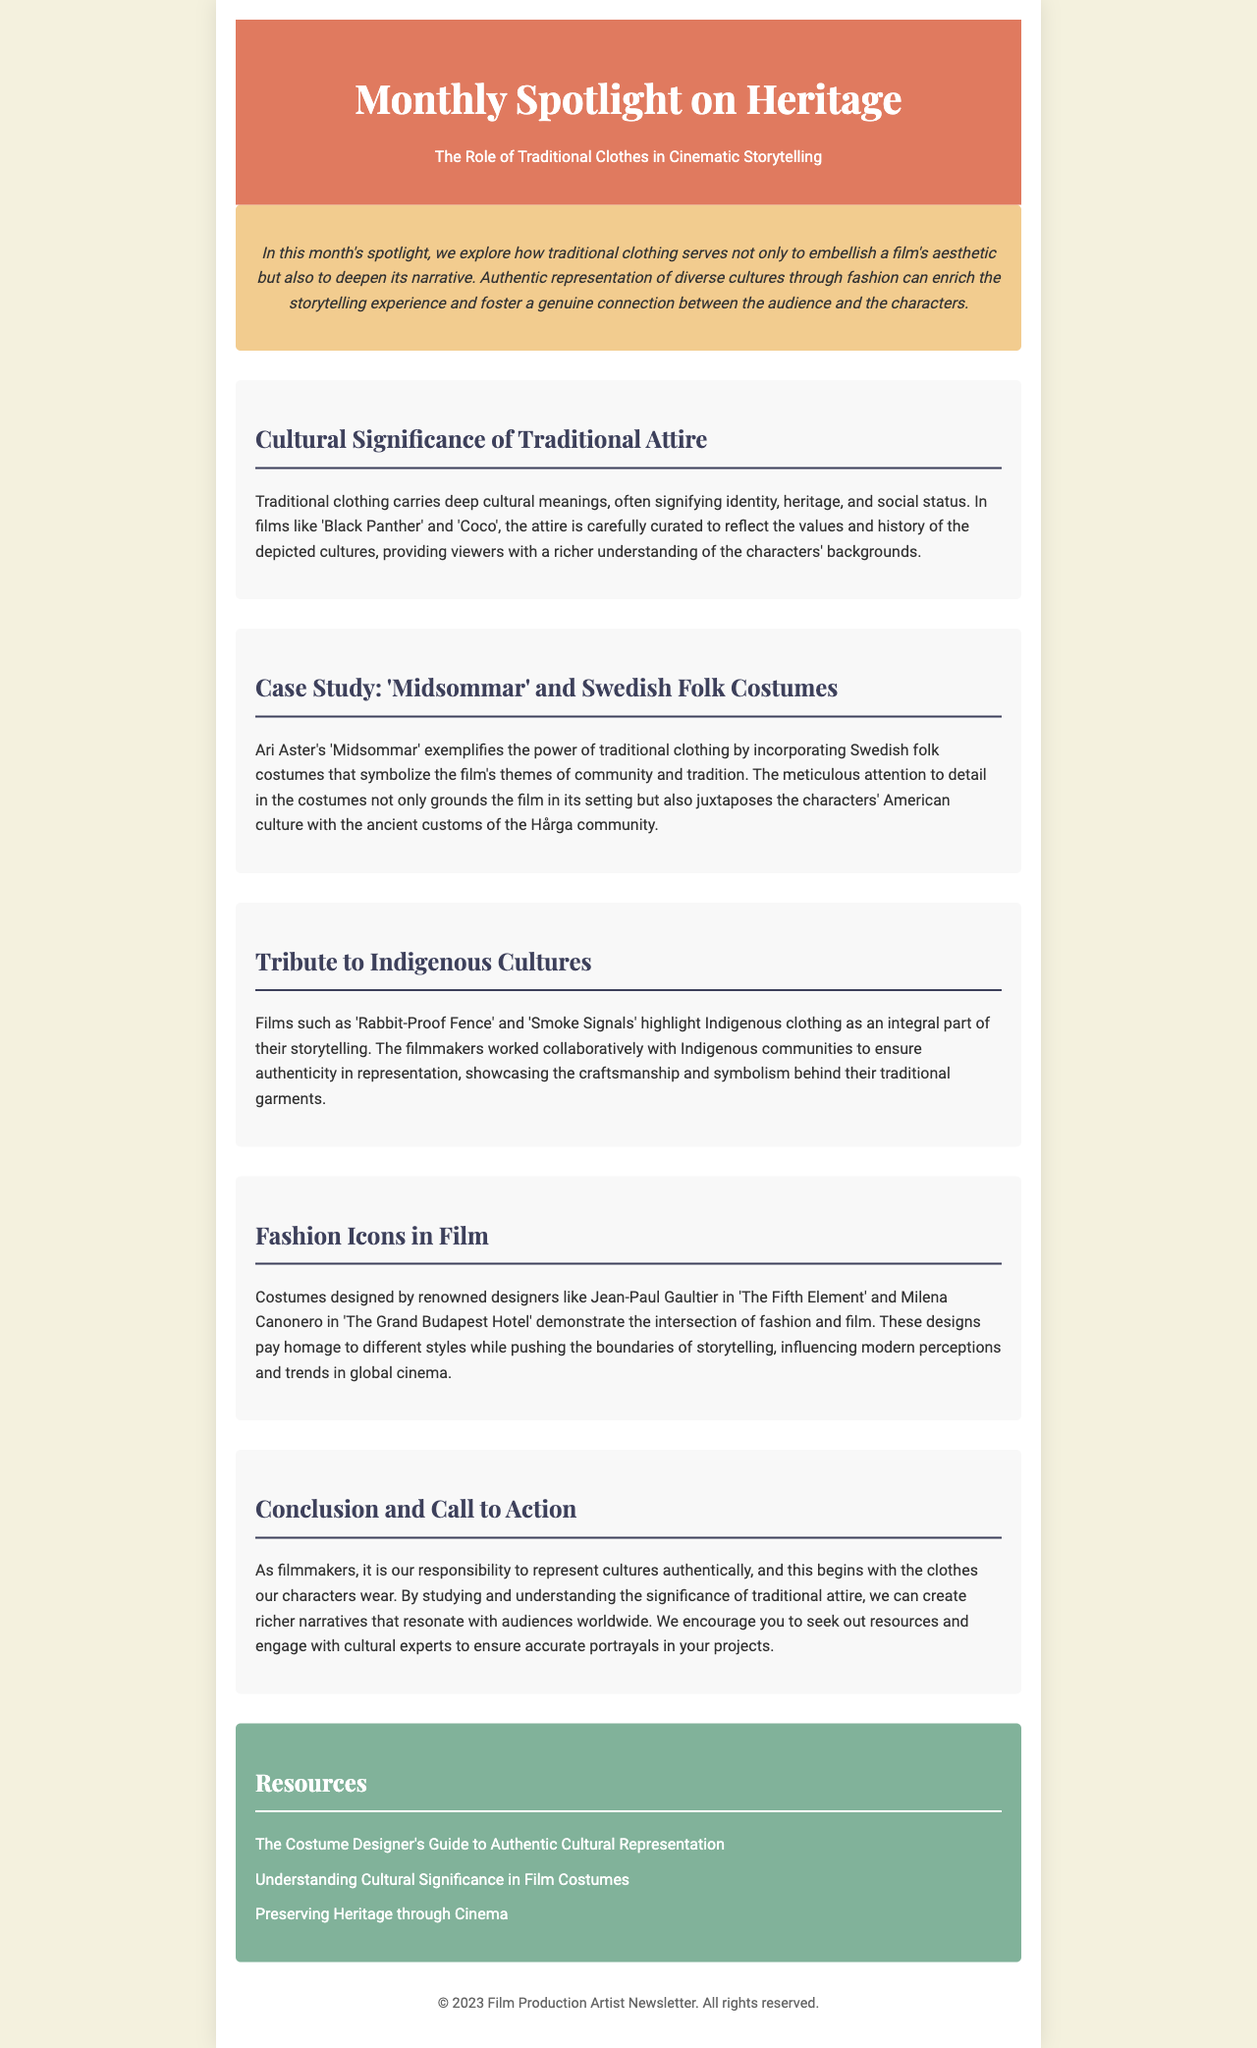What is the title of this newsletter? The title is stated in the header section of the document.
Answer: Monthly Spotlight on Heritage: The Role of Traditional Clothes in Cinematic Storytelling What is the culture highlighted in the case study? The case study specifically discusses the use of folk costumes within a film setting.
Answer: Swedish Which film is mentioned as an example of incorporating Indigenous clothing? The document lists notable films that feature Indigenous clothing as part of their storytelling.
Answer: Rabbit-Proof Fence What does the traditional clothing symbolize in 'Midsommar'? The document describes how traditional clothing relates to various themes within the film.
Answer: Community and tradition Who designed the costumes in 'The Fifth Element'? The document specifically mentions designers associated with particular films and their contributions.
Answer: Jean-Paul Gaultier How should filmmakers approach cultural representation according to the conclusion? The conclusion emphasizes a specific responsibility of filmmakers regarding culture in their work.
Answer: Authentically What color is used in the background of the header? The header background color is detailed within the style section of the code.
Answer: #e07a5f What is one resource mentioned for understanding cultural significance in film costumes? The resources section contains links to guides that provide further information.
Answer: The Costume Designer's Guide to Authentic Cultural Representation What type of clothing carries deep cultural meanings mentioned in the newsletter? The document refers to a specific type of clothing that reflects values and heritage.
Answer: Traditional clothing 